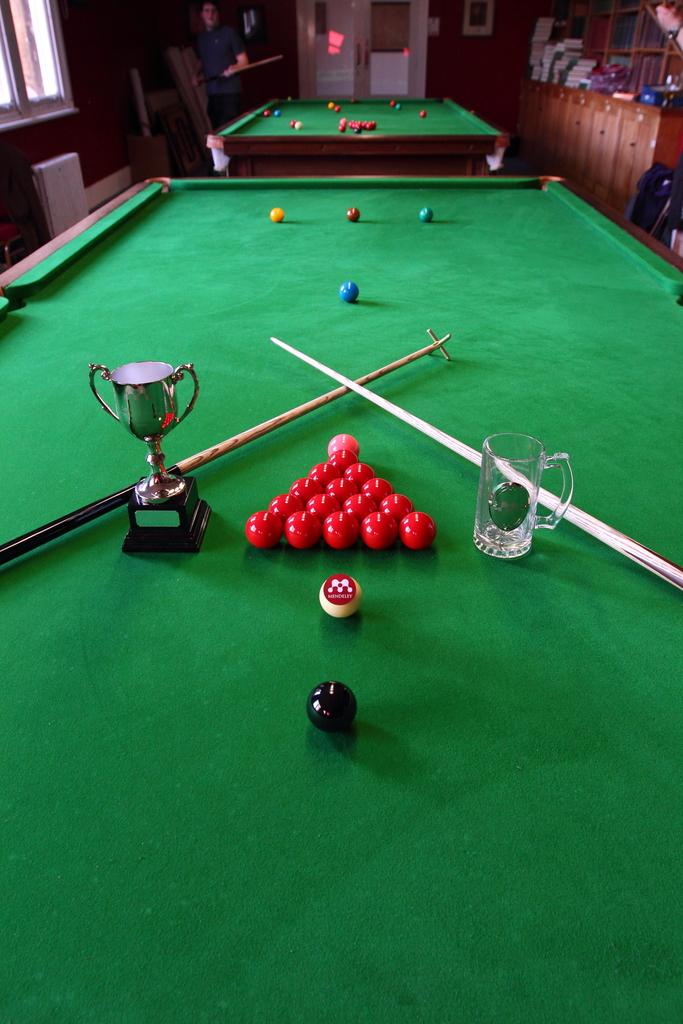What is placed on the billiards table in the image? There is a trophy, a glass mug, and balls on the billiards table. Can you describe the trophy on the billiards table? The trophy is a tall, shiny object with a base and a top, likely awarded for a competition or achievement. What else is on the billiards table besides the trophy? There is a glass mug and balls on the billiards table. What type of guide is present in the image to help with anger management? There is no guide or reference to anger management in the image; it features a billiards table with a trophy, a glass mug, and balls. 